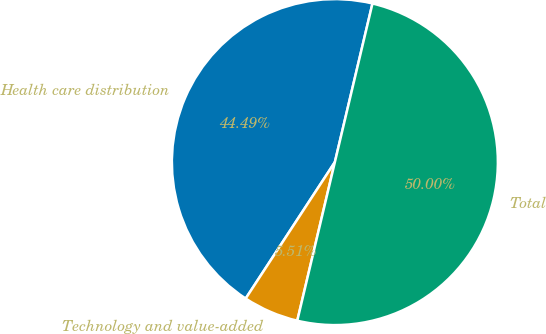Convert chart to OTSL. <chart><loc_0><loc_0><loc_500><loc_500><pie_chart><fcel>Health care distribution<fcel>Technology and value-added<fcel>Total<nl><fcel>44.49%<fcel>5.51%<fcel>50.0%<nl></chart> 